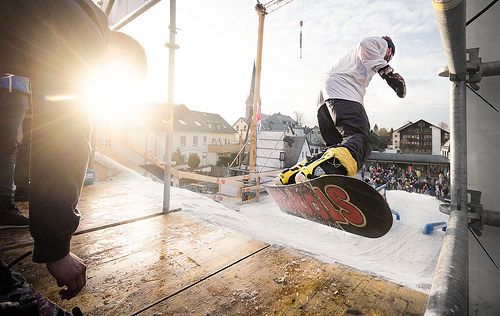<image>
Can you confirm if the man is in the sky? Yes. The man is contained within or inside the sky, showing a containment relationship. 